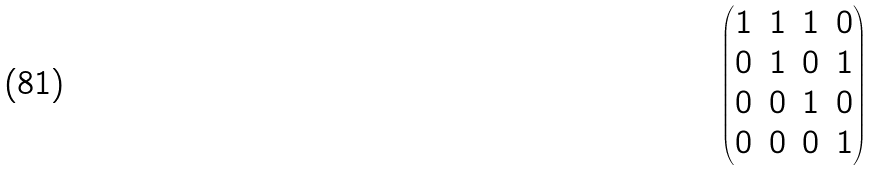Convert formula to latex. <formula><loc_0><loc_0><loc_500><loc_500>\begin{pmatrix} 1 & 1 & 1 & 0 \\ 0 & 1 & 0 & 1 \\ 0 & 0 & 1 & 0 \\ 0 & 0 & 0 & 1 \end{pmatrix}</formula> 